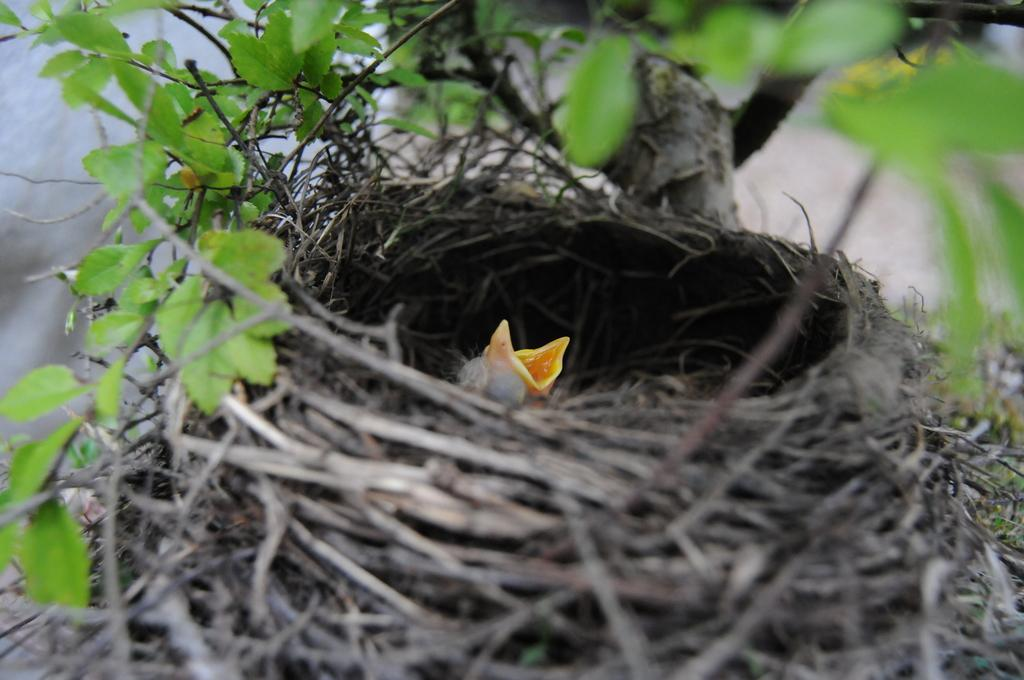What can be found in the image that is used by birds for shelter? There is a nest in the image that is used by birds for shelter. Is there a bird present in the nest? Yes, there is a bird in the nest. What can be seen in the background of the image? There are plants in the background of the image. What color are the plants in the image? The plants are green in color. Can you see any ice in the image? No, there is no ice present in the image. What type of can is visible in the image? There is no can present in the image. 